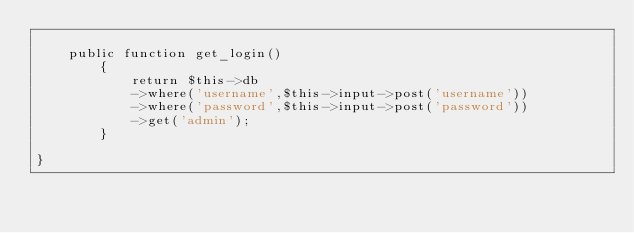Convert code to text. <code><loc_0><loc_0><loc_500><loc_500><_PHP_>
	public function get_login()
		{
			return $this->db
			->where('username',$this->input->post('username'))
			->where('password',$this->input->post('password'))
			->get('admin');
		}	

}</code> 